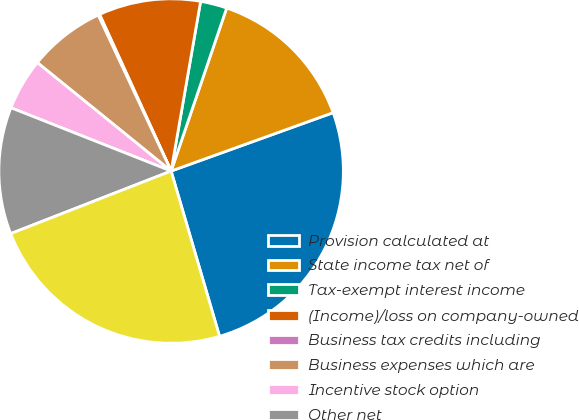Convert chart. <chart><loc_0><loc_0><loc_500><loc_500><pie_chart><fcel>Provision calculated at<fcel>State income tax net of<fcel>Tax-exempt interest income<fcel>(Income)/loss on company-owned<fcel>Business tax credits including<fcel>Business expenses which are<fcel>Incentive stock option<fcel>Other net<fcel>Total provision for income tax<nl><fcel>25.97%<fcel>14.27%<fcel>2.49%<fcel>9.56%<fcel>0.14%<fcel>7.2%<fcel>4.85%<fcel>11.91%<fcel>23.62%<nl></chart> 